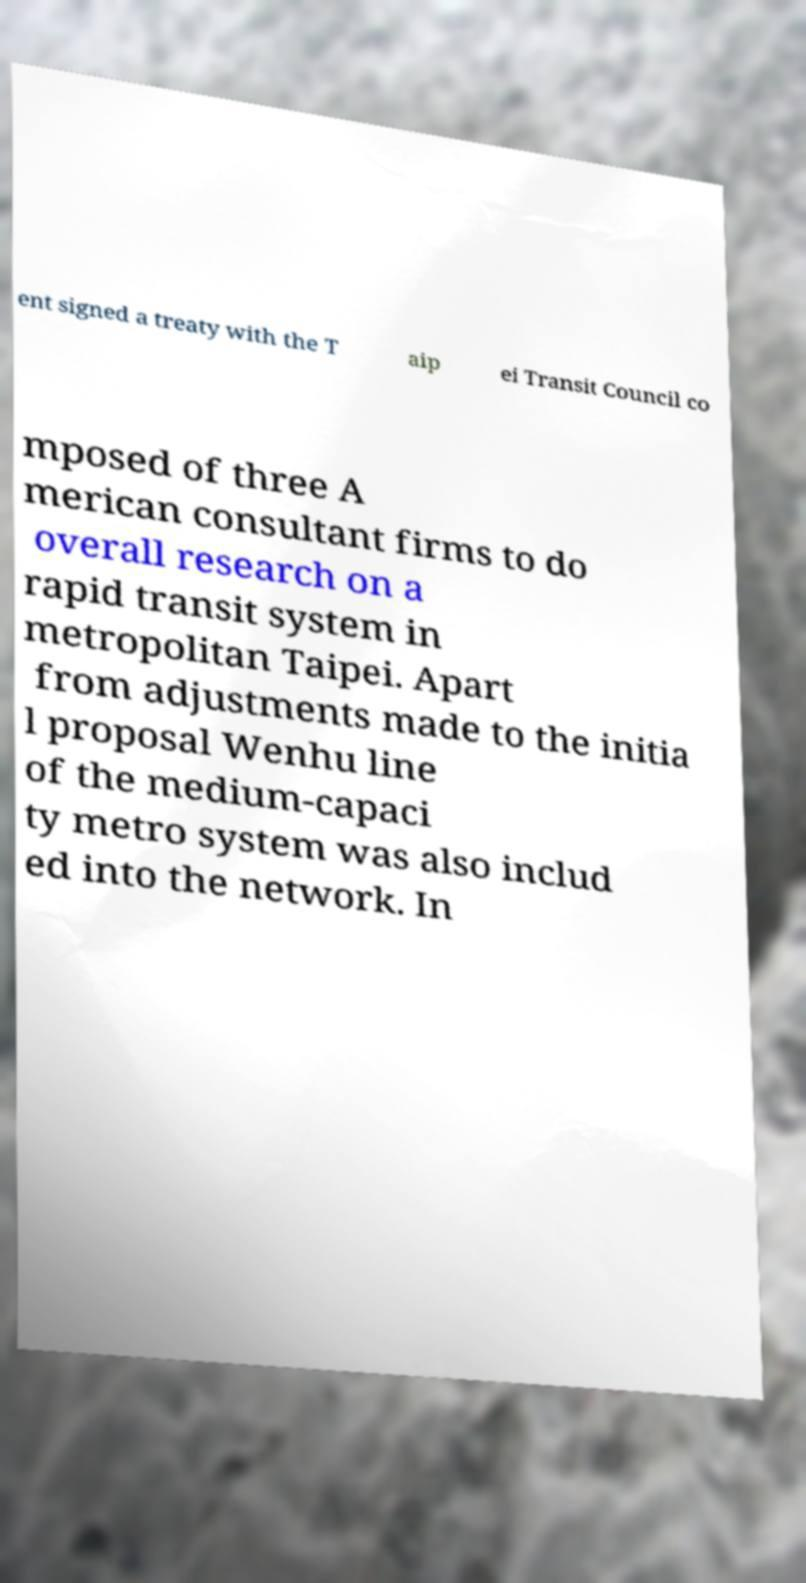What messages or text are displayed in this image? I need them in a readable, typed format. ent signed a treaty with the T aip ei Transit Council co mposed of three A merican consultant firms to do overall research on a rapid transit system in metropolitan Taipei. Apart from adjustments made to the initia l proposal Wenhu line of the medium-capaci ty metro system was also includ ed into the network. In 